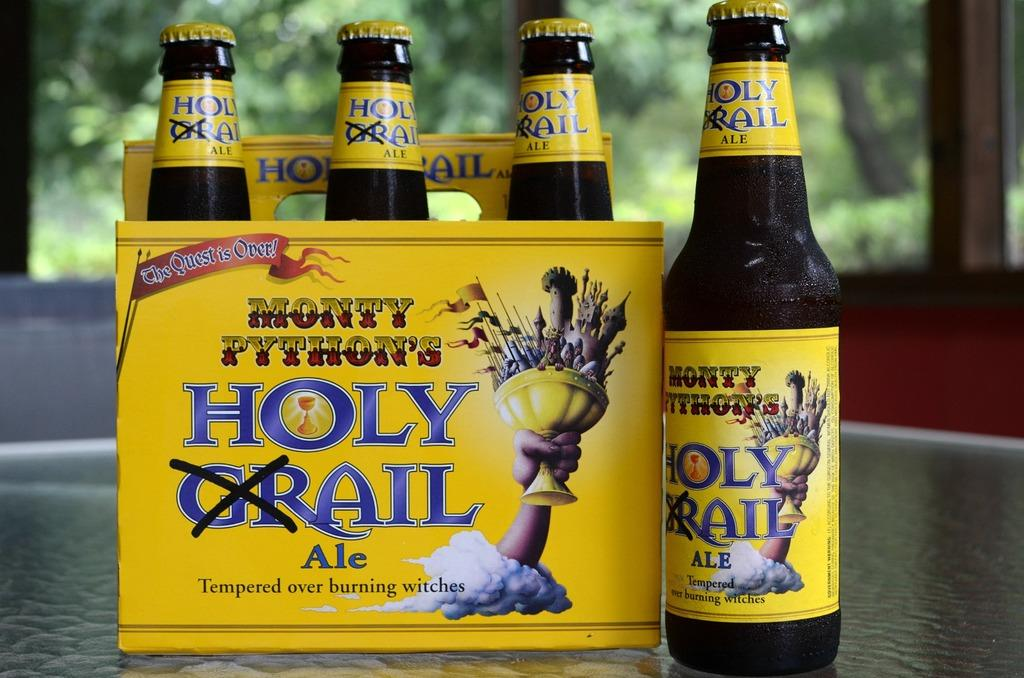Provide a one-sentence caption for the provided image. Six pack of holy grail ale the quest is over drinks. 